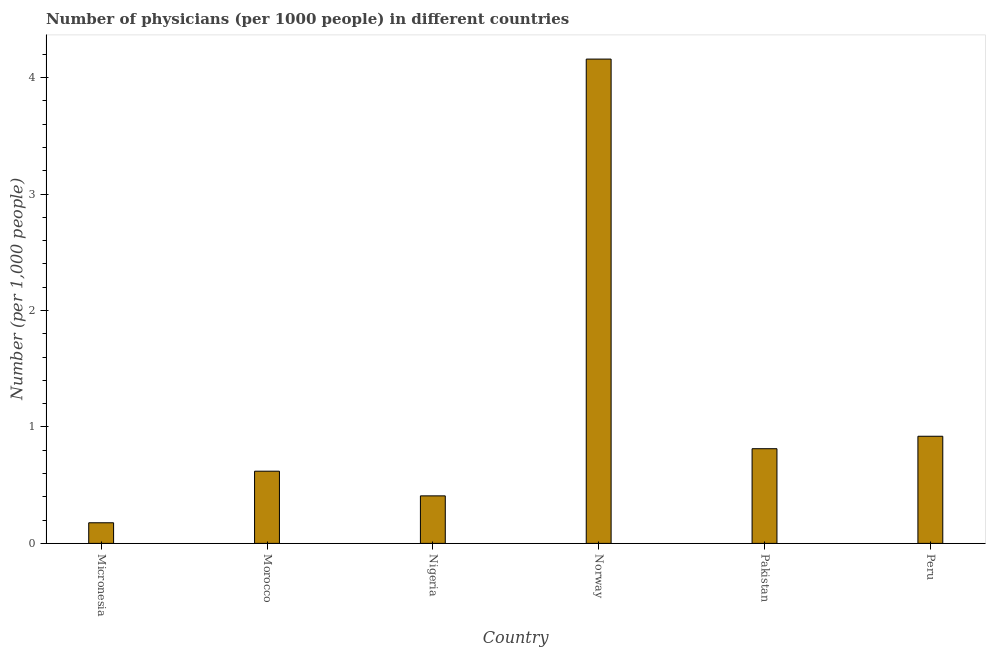Does the graph contain any zero values?
Your answer should be very brief. No. What is the title of the graph?
Make the answer very short. Number of physicians (per 1000 people) in different countries. What is the label or title of the Y-axis?
Ensure brevity in your answer.  Number (per 1,0 people). What is the number of physicians in Morocco?
Keep it short and to the point. 0.62. Across all countries, what is the maximum number of physicians?
Your response must be concise. 4.16. Across all countries, what is the minimum number of physicians?
Provide a short and direct response. 0.18. In which country was the number of physicians maximum?
Offer a terse response. Norway. In which country was the number of physicians minimum?
Offer a terse response. Micronesia. What is the sum of the number of physicians?
Provide a short and direct response. 7.1. What is the difference between the number of physicians in Nigeria and Norway?
Keep it short and to the point. -3.75. What is the average number of physicians per country?
Your answer should be very brief. 1.18. What is the median number of physicians?
Offer a terse response. 0.72. In how many countries, is the number of physicians greater than 3.2 ?
Make the answer very short. 1. What is the ratio of the number of physicians in Morocco to that in Nigeria?
Provide a succinct answer. 1.52. Is the number of physicians in Nigeria less than that in Pakistan?
Offer a terse response. Yes. What is the difference between the highest and the second highest number of physicians?
Give a very brief answer. 3.24. Is the sum of the number of physicians in Norway and Pakistan greater than the maximum number of physicians across all countries?
Make the answer very short. Yes. What is the difference between the highest and the lowest number of physicians?
Provide a succinct answer. 3.98. What is the difference between two consecutive major ticks on the Y-axis?
Ensure brevity in your answer.  1. What is the Number (per 1,000 people) in Micronesia?
Offer a terse response. 0.18. What is the Number (per 1,000 people) of Morocco?
Your response must be concise. 0.62. What is the Number (per 1,000 people) in Nigeria?
Make the answer very short. 0.41. What is the Number (per 1,000 people) in Norway?
Your answer should be very brief. 4.16. What is the Number (per 1,000 people) of Pakistan?
Give a very brief answer. 0.81. What is the Number (per 1,000 people) of Peru?
Provide a short and direct response. 0.92. What is the difference between the Number (per 1,000 people) in Micronesia and Morocco?
Offer a terse response. -0.44. What is the difference between the Number (per 1,000 people) in Micronesia and Nigeria?
Ensure brevity in your answer.  -0.23. What is the difference between the Number (per 1,000 people) in Micronesia and Norway?
Offer a very short reply. -3.98. What is the difference between the Number (per 1,000 people) in Micronesia and Pakistan?
Ensure brevity in your answer.  -0.64. What is the difference between the Number (per 1,000 people) in Micronesia and Peru?
Offer a very short reply. -0.74. What is the difference between the Number (per 1,000 people) in Morocco and Nigeria?
Make the answer very short. 0.21. What is the difference between the Number (per 1,000 people) in Morocco and Norway?
Keep it short and to the point. -3.54. What is the difference between the Number (per 1,000 people) in Morocco and Pakistan?
Your answer should be very brief. -0.19. What is the difference between the Number (per 1,000 people) in Nigeria and Norway?
Your response must be concise. -3.75. What is the difference between the Number (per 1,000 people) in Nigeria and Pakistan?
Your answer should be very brief. -0.41. What is the difference between the Number (per 1,000 people) in Nigeria and Peru?
Provide a succinct answer. -0.51. What is the difference between the Number (per 1,000 people) in Norway and Pakistan?
Ensure brevity in your answer.  3.35. What is the difference between the Number (per 1,000 people) in Norway and Peru?
Make the answer very short. 3.24. What is the difference between the Number (per 1,000 people) in Pakistan and Peru?
Ensure brevity in your answer.  -0.11. What is the ratio of the Number (per 1,000 people) in Micronesia to that in Morocco?
Offer a terse response. 0.28. What is the ratio of the Number (per 1,000 people) in Micronesia to that in Nigeria?
Provide a succinct answer. 0.43. What is the ratio of the Number (per 1,000 people) in Micronesia to that in Norway?
Make the answer very short. 0.04. What is the ratio of the Number (per 1,000 people) in Micronesia to that in Pakistan?
Ensure brevity in your answer.  0.22. What is the ratio of the Number (per 1,000 people) in Micronesia to that in Peru?
Ensure brevity in your answer.  0.19. What is the ratio of the Number (per 1,000 people) in Morocco to that in Nigeria?
Your answer should be very brief. 1.52. What is the ratio of the Number (per 1,000 people) in Morocco to that in Norway?
Offer a terse response. 0.15. What is the ratio of the Number (per 1,000 people) in Morocco to that in Pakistan?
Give a very brief answer. 0.76. What is the ratio of the Number (per 1,000 people) in Morocco to that in Peru?
Offer a terse response. 0.67. What is the ratio of the Number (per 1,000 people) in Nigeria to that in Norway?
Offer a terse response. 0.1. What is the ratio of the Number (per 1,000 people) in Nigeria to that in Pakistan?
Your answer should be very brief. 0.5. What is the ratio of the Number (per 1,000 people) in Nigeria to that in Peru?
Provide a succinct answer. 0.44. What is the ratio of the Number (per 1,000 people) in Norway to that in Pakistan?
Keep it short and to the point. 5.12. What is the ratio of the Number (per 1,000 people) in Norway to that in Peru?
Give a very brief answer. 4.52. What is the ratio of the Number (per 1,000 people) in Pakistan to that in Peru?
Your answer should be very brief. 0.88. 